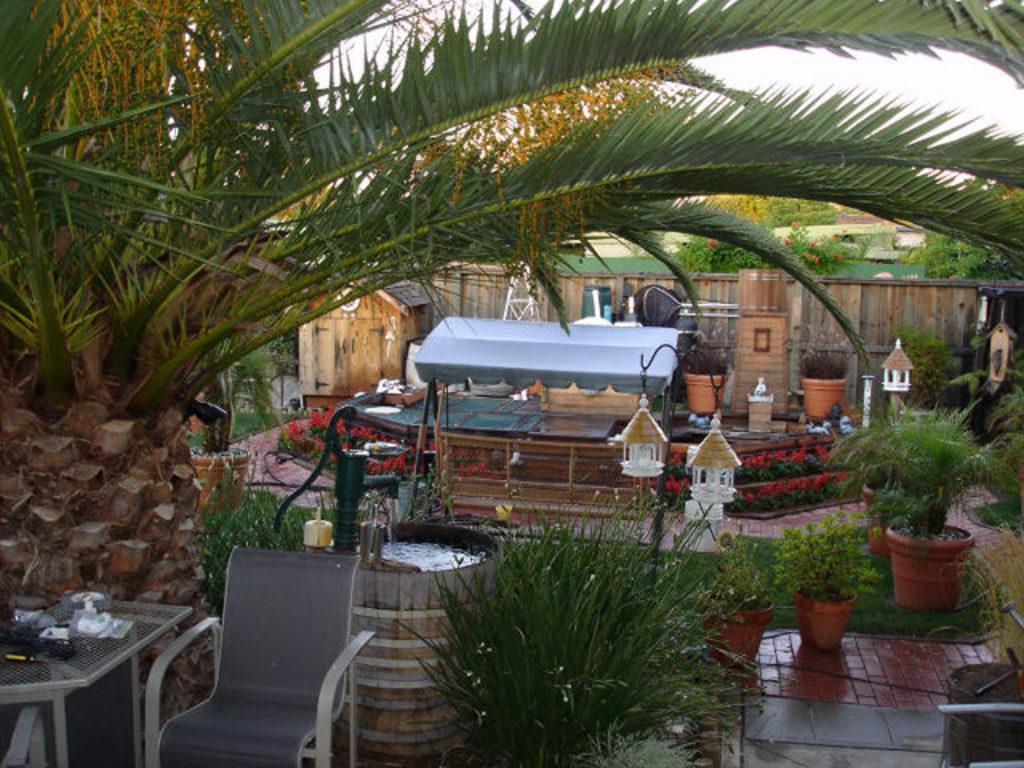How would you summarize this image in a sentence or two? In this picture there is a table, chair and a well at the bottom side of the image and there is a swing in the center of the image, there are plant pots around the swing and there is a house in the background area of the image and there is greenery around the area of the image. 